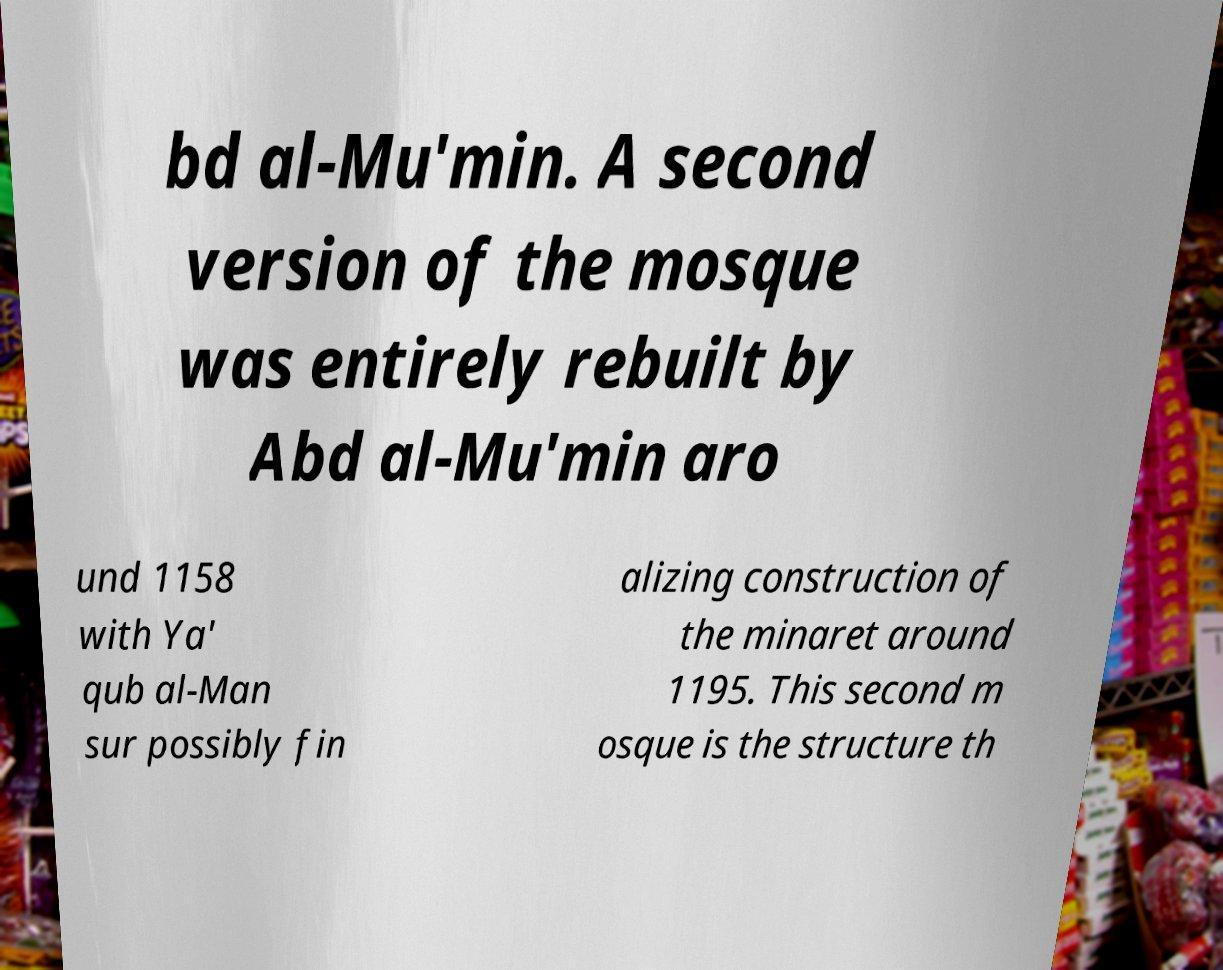What messages or text are displayed in this image? I need them in a readable, typed format. bd al-Mu'min. A second version of the mosque was entirely rebuilt by Abd al-Mu'min aro und 1158 with Ya' qub al-Man sur possibly fin alizing construction of the minaret around 1195. This second m osque is the structure th 